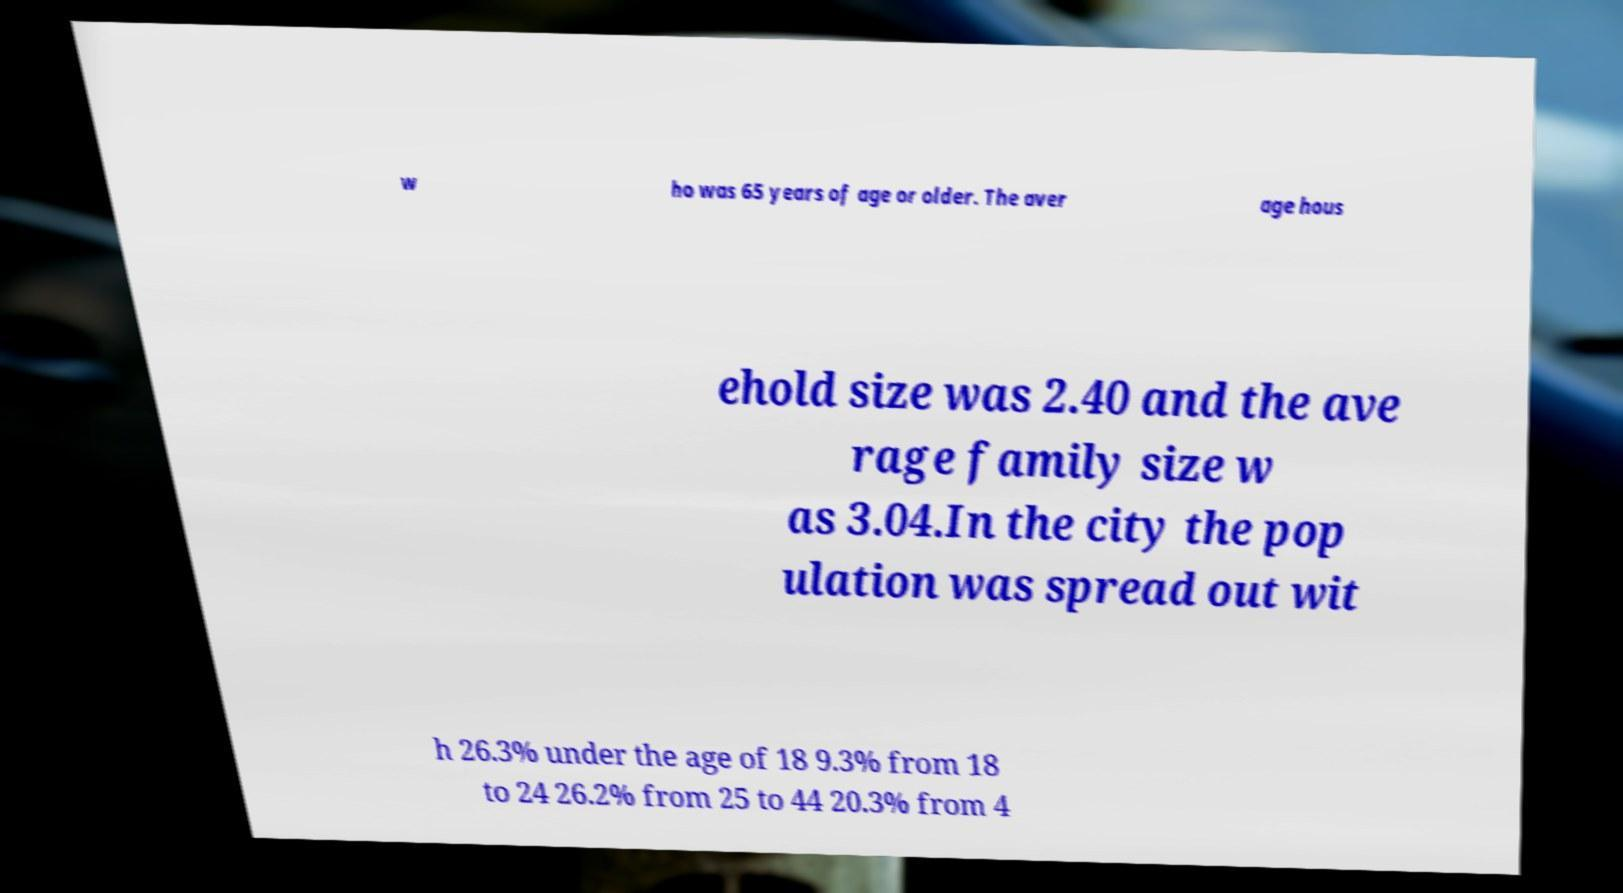There's text embedded in this image that I need extracted. Can you transcribe it verbatim? w ho was 65 years of age or older. The aver age hous ehold size was 2.40 and the ave rage family size w as 3.04.In the city the pop ulation was spread out wit h 26.3% under the age of 18 9.3% from 18 to 24 26.2% from 25 to 44 20.3% from 4 